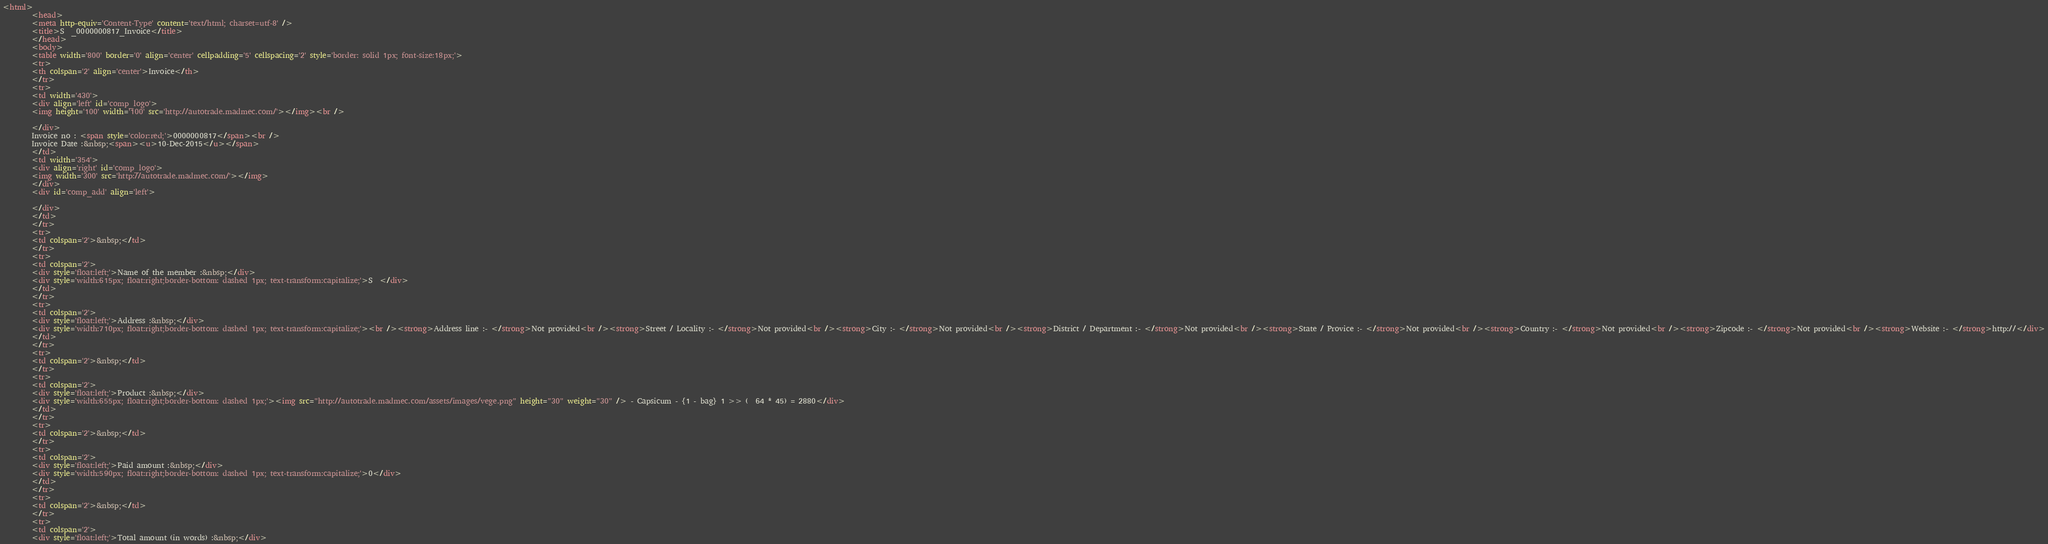Convert code to text. <code><loc_0><loc_0><loc_500><loc_500><_HTML_><html>
		<head>
		<meta http-equiv='Content-Type' content='text/html; charset=utf-8' />
		<title>S  _0000000817_Invoice</title>
		</head>
		<body>
		<table width='800' border='0' align='center' cellpadding='5' cellspacing='2' style='border: solid 1px; font-size:18px;'>
		<tr>
		<th colspan='2' align='center'>Invoice</th>
		</tr>
		<tr>
		<td width='430'>
		<div align='left' id='comp_logo'>
		<img height='100' width='100' src='http://autotrade.madmec.com/'></img><br />

		</div>
		Invoice no : <span style='color:red;'>0000000817</span><br />
		Invoice Date :&nbsp;<span><u>10-Dec-2015</u></span>
		</td>
		<td width='354'>
		<div align='right' id='comp_logo'>
		<img width='300' src='http://autotrade.madmec.com/'></img>
		</div>
		<div id='comp_add' align='left'>
		
		</div>
		</td>
		</tr>
		<tr>
		<td colspan='2'>&nbsp;</td>
		</tr>
		<tr>
		<td colspan='2'>
		<div style='float:left;'>Name of the member :&nbsp;</div>
		<div style='width:615px; float:right;border-bottom: dashed 1px; text-transform:capitalize;'>S  </div>
		</td>
		</tr>
		<tr>
		<td colspan='2'>
		<div style='float:left;'>Address :&nbsp;</div>
		<div style='width:710px; float:right;border-bottom: dashed 1px; text-transform:capitalize;'><br /><strong>Address line :- </strong>Not provided<br /><strong>Street / Locality :- </strong>Not provided<br /><strong>City :- </strong>Not provided<br /><strong>District / Department :- </strong>Not provided<br /><strong>State / Provice :- </strong>Not provided<br /><strong>Country :- </strong>Not provided<br /><strong>Zipcode :- </strong>Not provided<br /><strong>Website :- </strong>http://</div>
		</td>
		</tr>
		<tr>
		<td colspan='2'>&nbsp;</td>
		</tr>
		<tr>
		<td colspan='2'>
		<div style='float:left;'>Product :&nbsp;</div>
		<div style='width:655px; float:right;border-bottom: dashed 1px;'><img src="http://autotrade.madmec.com/assets/images/vege.png" height="30" weight="30" /> - Capsicum - {1 - bag} 1 >> (  64 * 45) = 2880</div>
		</td>
		</tr>
		<tr>
		<td colspan='2'>&nbsp;</td>
		</tr>
		<tr>
		<td colspan='2'>
		<div style='float:left;'>Paid amount :&nbsp;</div>
		<div style='width:590px; float:right;border-bottom: dashed 1px; text-transform:capitalize;'>0</div>
		</td>
		</tr>
		<tr>
		<td colspan='2'>&nbsp;</td>
		</tr>
		<tr>
		<td colspan='2'>
		<div style='float:left;'>Total amount (in words) :&nbsp;</div></code> 